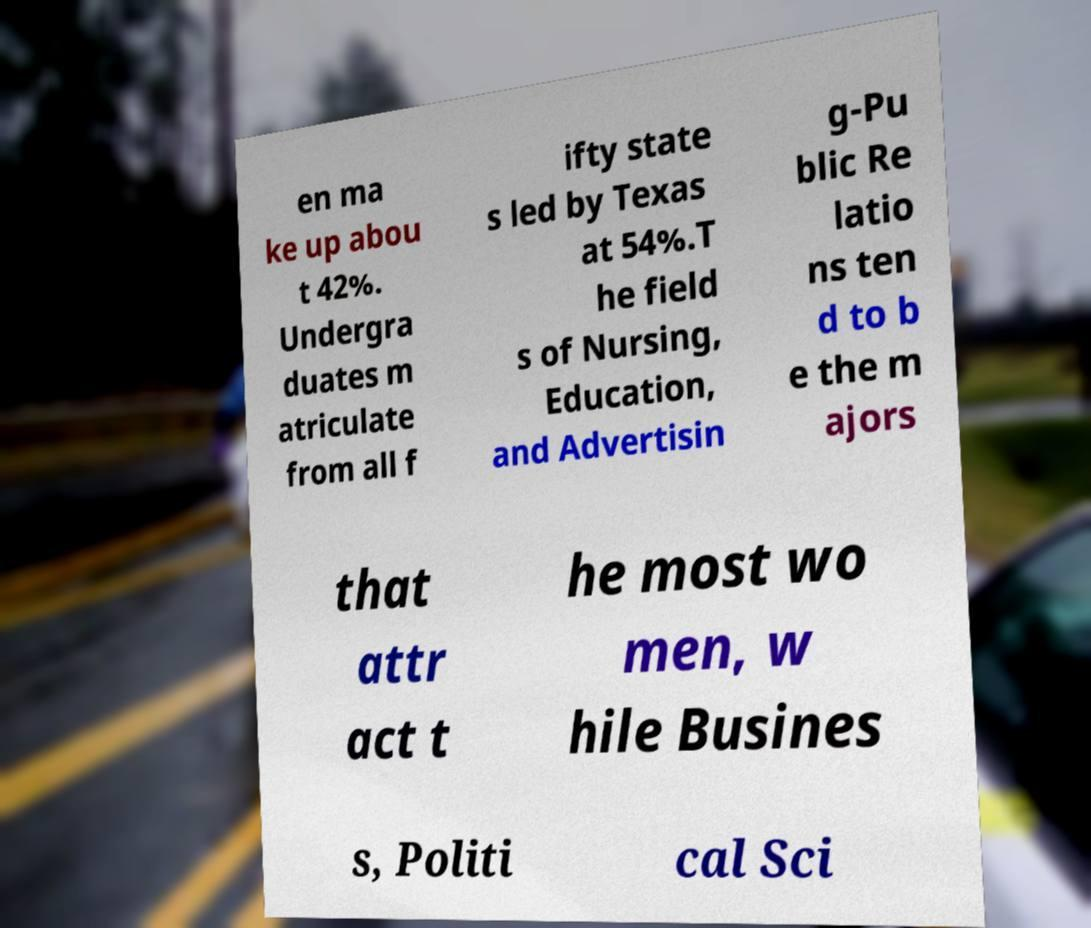There's text embedded in this image that I need extracted. Can you transcribe it verbatim? en ma ke up abou t 42%. Undergra duates m atriculate from all f ifty state s led by Texas at 54%.T he field s of Nursing, Education, and Advertisin g-Pu blic Re latio ns ten d to b e the m ajors that attr act t he most wo men, w hile Busines s, Politi cal Sci 